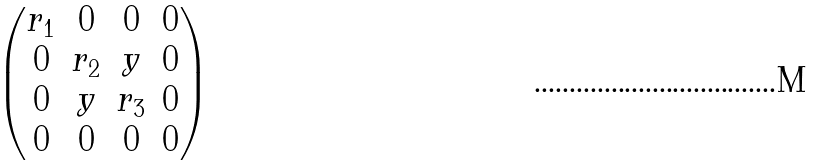<formula> <loc_0><loc_0><loc_500><loc_500>\begin{pmatrix} r _ { 1 } & 0 & 0 & 0 \\ 0 & r _ { 2 } & y & 0 \\ 0 & y & r _ { 3 } & 0 \\ 0 & 0 & 0 & 0 \end{pmatrix}</formula> 